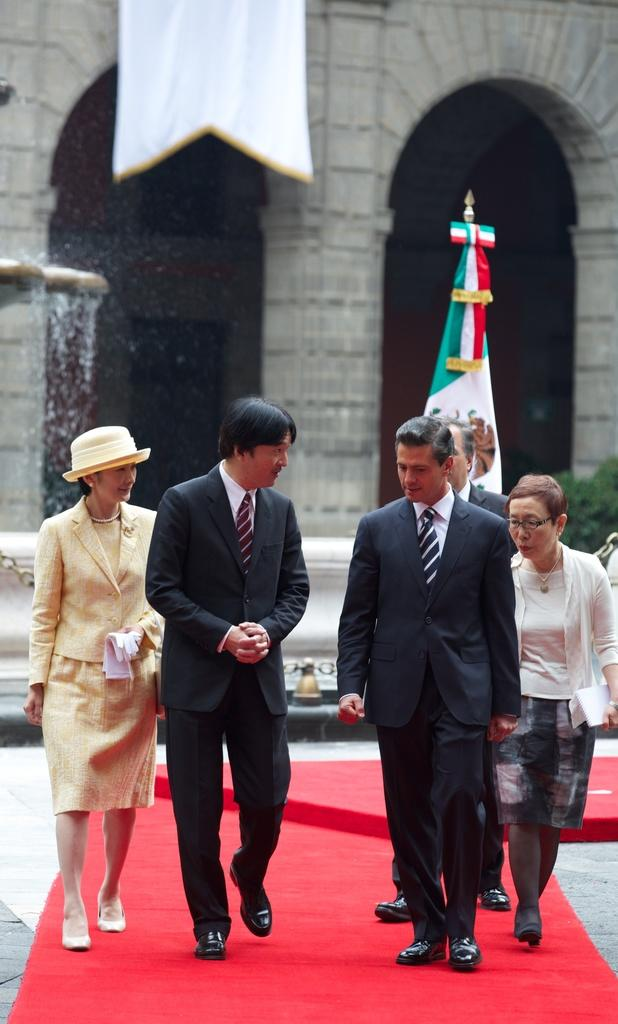How many people are present in the image? There are five persons standing in the image. What can be seen in the background of the image? There is a building in the background of the image. What is visible on the left side of the image? There is water visible on the left side of the image. What object is present in the image that represents a country or organization? There is a flag in the image. What type of vegetation is in the middle of the image? There is a plant in the middle of the image. What type of cough can be heard from the person on the right side of the image? There is no indication of any cough or sound in the image, so it cannot be determined. --- Facts: 1. There is a car in the image. 2. The car is red. 3. The car has four wheels. 4. There is a road in the image. 5. The road is paved. Absurd Topics: bird, dance, mountain Conversation: What type of vehicle is in the image? There is a car in the image. What color is the car? The car is red. How many wheels does the car have? The car has four wheels. What type of surface is visible in the image? There is a road in the image, and it is paved. Reasoning: Let's think step by step in order to produce the conversation. We start by identifying the main subject in the image, which is the car. Then, we describe the car's color and the number of wheels it has. Next, we mention the road in the image and its paved surface. Each question is designed to elicit a specific detail about the image that is known from the provided facts. Absurd Question/Answer: What type of bird can be seen flying over the mountain in the image? There is no mountain or bird present in the image; it features a red car on a paved road. 